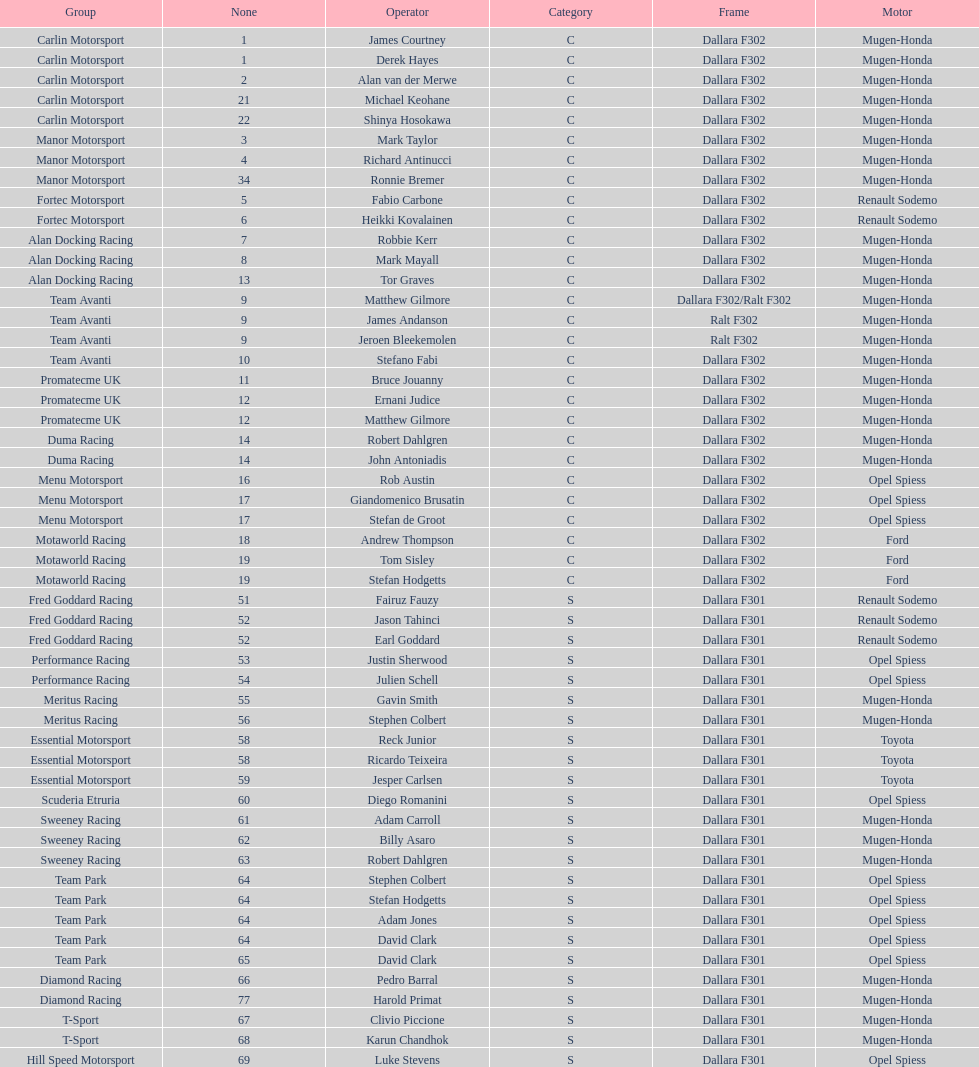How many teams had at least two drivers this season? 17. 